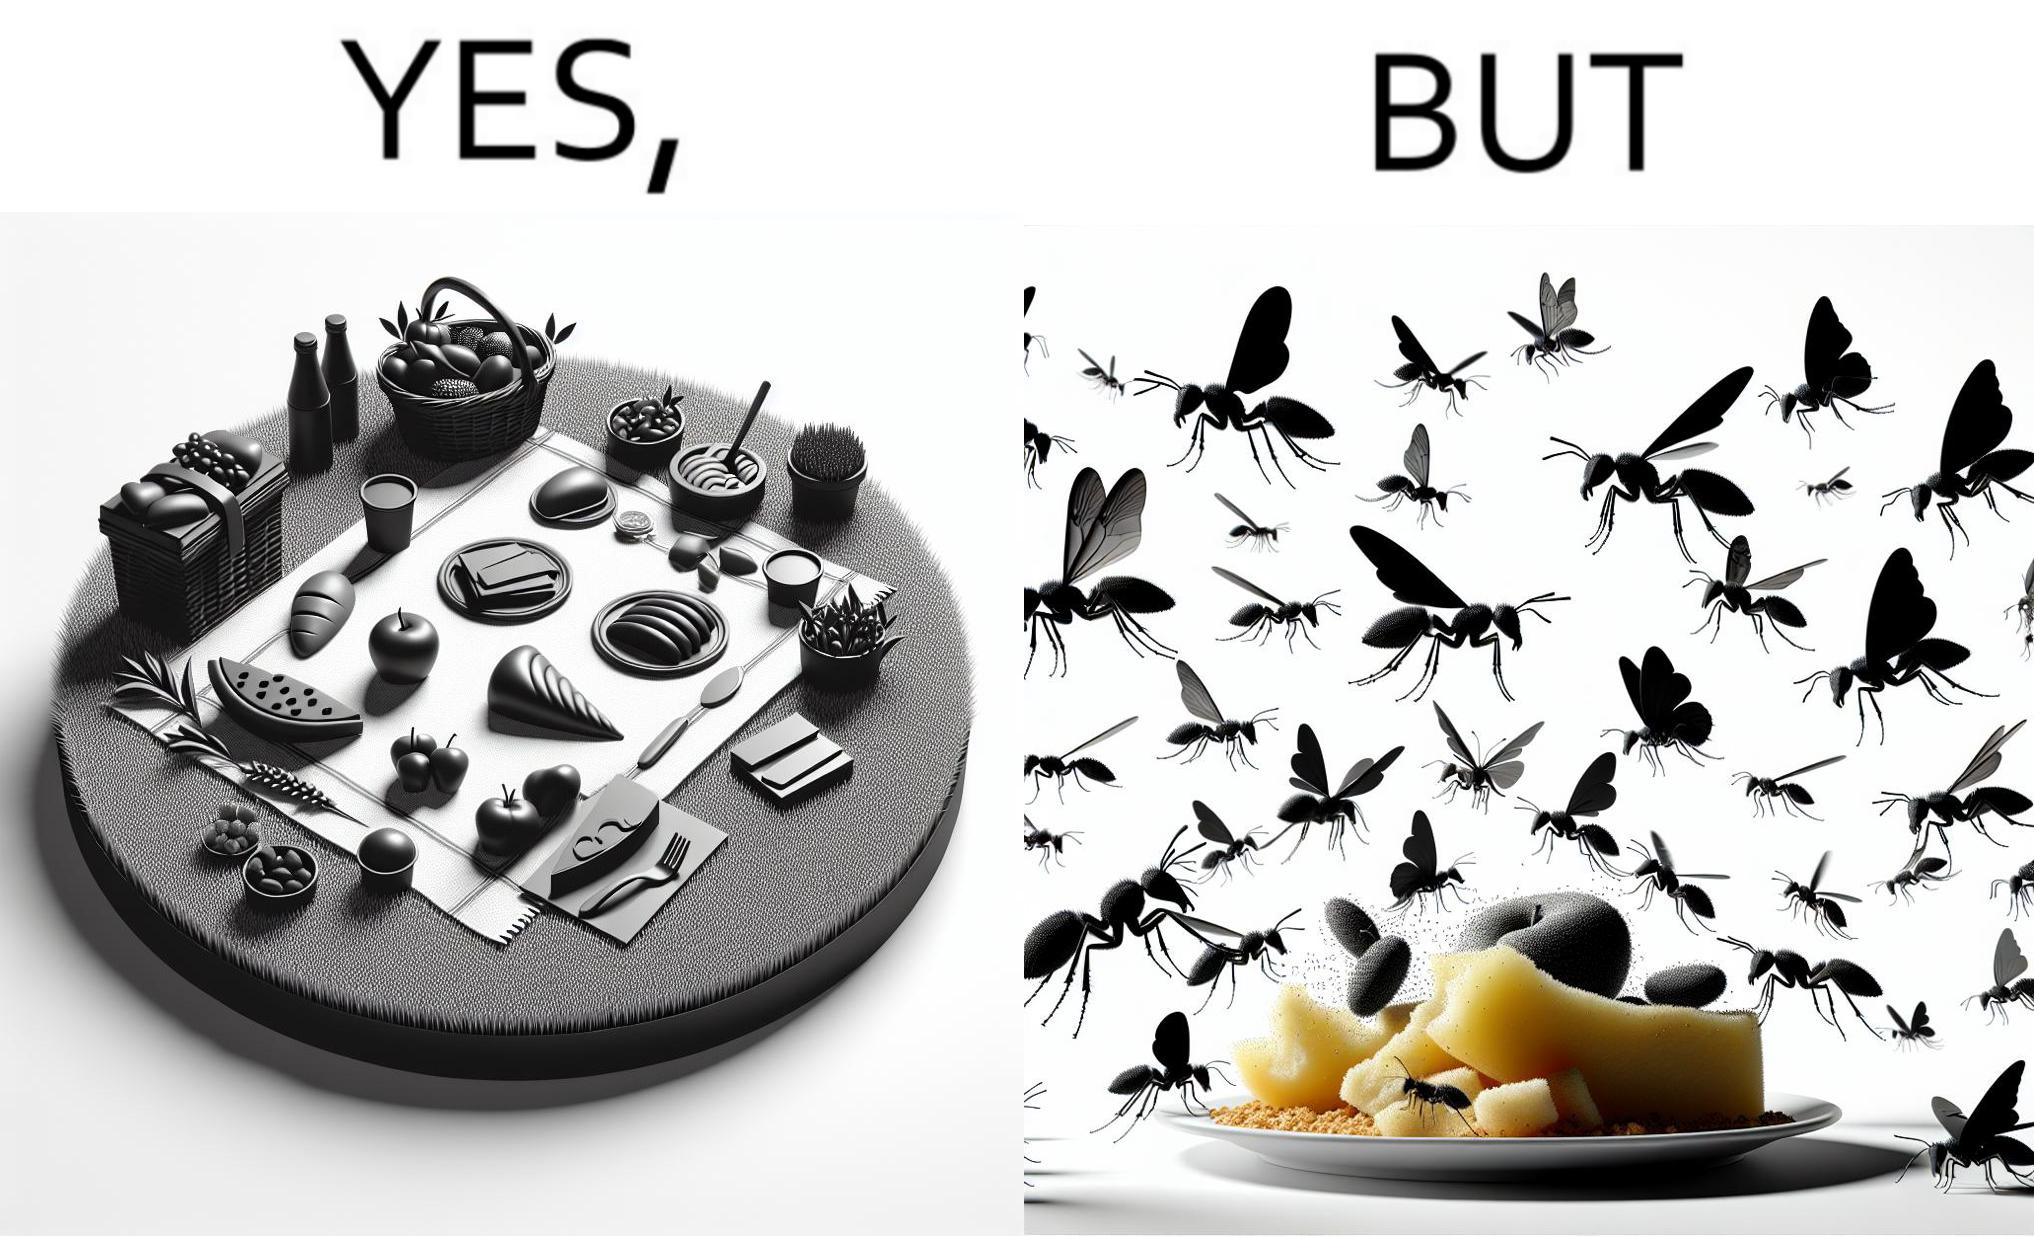Does this image contain satire or humor? Yes, this image is satirical. 